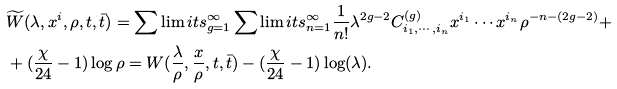<formula> <loc_0><loc_0><loc_500><loc_500>& \widetilde { W } ( \lambda , x ^ { i } , \rho , t , \bar { t } ) = \sum \lim i t s _ { g = 1 } ^ { \infty } \sum \lim i t s _ { n = 1 } ^ { \infty } \frac { 1 } { n ! } \lambda ^ { 2 g - 2 } C _ { i _ { 1 } , \cdots , i _ { n } } ^ { ( g ) } x ^ { i _ { 1 } } \cdots x ^ { i _ { n } } \rho ^ { - n - ( 2 g - 2 ) } + \\ & + ( \frac { \chi } { 2 4 } - 1 ) \log \rho = W ( \frac { \lambda } { \rho } , \frac { x } { \rho } , t , \bar { t } ) - ( \frac { \chi } { 2 4 } - 1 ) \log ( \lambda ) .</formula> 